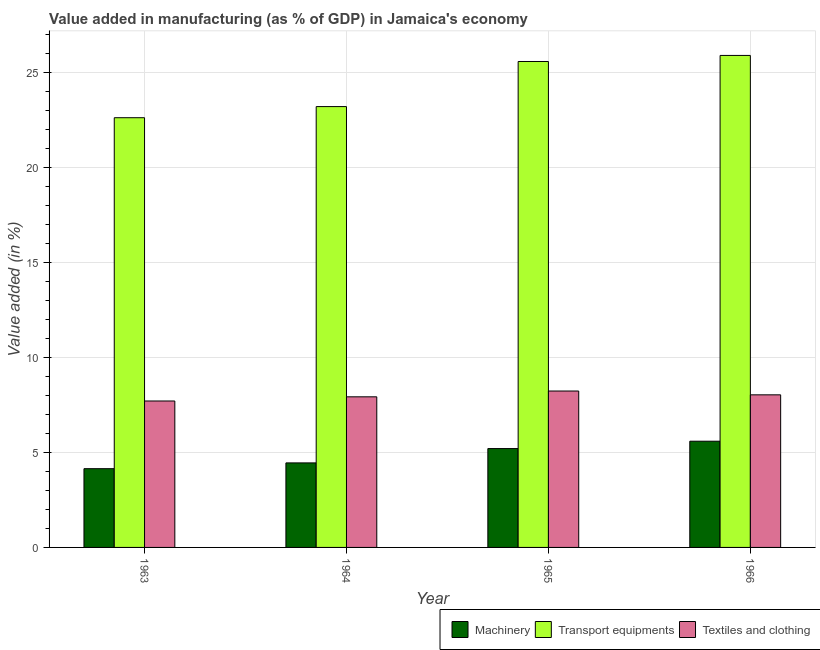How many bars are there on the 1st tick from the right?
Ensure brevity in your answer.  3. What is the label of the 3rd group of bars from the left?
Your answer should be compact. 1965. What is the value added in manufacturing transport equipments in 1964?
Provide a succinct answer. 23.21. Across all years, what is the maximum value added in manufacturing transport equipments?
Your answer should be very brief. 25.9. Across all years, what is the minimum value added in manufacturing transport equipments?
Offer a very short reply. 22.62. In which year was the value added in manufacturing transport equipments maximum?
Offer a terse response. 1966. In which year was the value added in manufacturing machinery minimum?
Offer a terse response. 1963. What is the total value added in manufacturing machinery in the graph?
Make the answer very short. 19.39. What is the difference between the value added in manufacturing machinery in 1963 and that in 1966?
Offer a very short reply. -1.45. What is the difference between the value added in manufacturing transport equipments in 1966 and the value added in manufacturing textile and clothing in 1964?
Your answer should be very brief. 2.69. What is the average value added in manufacturing textile and clothing per year?
Your response must be concise. 7.98. In the year 1966, what is the difference between the value added in manufacturing machinery and value added in manufacturing transport equipments?
Keep it short and to the point. 0. In how many years, is the value added in manufacturing machinery greater than 3 %?
Your response must be concise. 4. What is the ratio of the value added in manufacturing machinery in 1964 to that in 1965?
Give a very brief answer. 0.86. Is the difference between the value added in manufacturing transport equipments in 1963 and 1965 greater than the difference between the value added in manufacturing textile and clothing in 1963 and 1965?
Make the answer very short. No. What is the difference between the highest and the second highest value added in manufacturing textile and clothing?
Your response must be concise. 0.2. What is the difference between the highest and the lowest value added in manufacturing machinery?
Your response must be concise. 1.45. What does the 3rd bar from the left in 1963 represents?
Ensure brevity in your answer.  Textiles and clothing. What does the 3rd bar from the right in 1966 represents?
Your answer should be compact. Machinery. Are all the bars in the graph horizontal?
Your response must be concise. No. Does the graph contain any zero values?
Provide a short and direct response. No. How many legend labels are there?
Offer a terse response. 3. How are the legend labels stacked?
Provide a succinct answer. Horizontal. What is the title of the graph?
Provide a short and direct response. Value added in manufacturing (as % of GDP) in Jamaica's economy. Does "Ireland" appear as one of the legend labels in the graph?
Provide a short and direct response. No. What is the label or title of the X-axis?
Keep it short and to the point. Year. What is the label or title of the Y-axis?
Your answer should be compact. Value added (in %). What is the Value added (in %) of Machinery in 1963?
Provide a short and direct response. 4.15. What is the Value added (in %) in Transport equipments in 1963?
Provide a succinct answer. 22.62. What is the Value added (in %) in Textiles and clothing in 1963?
Make the answer very short. 7.71. What is the Value added (in %) in Machinery in 1964?
Keep it short and to the point. 4.45. What is the Value added (in %) of Transport equipments in 1964?
Provide a short and direct response. 23.21. What is the Value added (in %) in Textiles and clothing in 1964?
Provide a succinct answer. 7.93. What is the Value added (in %) in Machinery in 1965?
Your answer should be very brief. 5.2. What is the Value added (in %) of Transport equipments in 1965?
Your answer should be compact. 25.58. What is the Value added (in %) in Textiles and clothing in 1965?
Keep it short and to the point. 8.23. What is the Value added (in %) in Machinery in 1966?
Ensure brevity in your answer.  5.59. What is the Value added (in %) in Transport equipments in 1966?
Make the answer very short. 25.9. What is the Value added (in %) of Textiles and clothing in 1966?
Give a very brief answer. 8.03. Across all years, what is the maximum Value added (in %) of Machinery?
Your answer should be compact. 5.59. Across all years, what is the maximum Value added (in %) of Transport equipments?
Your answer should be very brief. 25.9. Across all years, what is the maximum Value added (in %) in Textiles and clothing?
Keep it short and to the point. 8.23. Across all years, what is the minimum Value added (in %) in Machinery?
Provide a succinct answer. 4.15. Across all years, what is the minimum Value added (in %) of Transport equipments?
Make the answer very short. 22.62. Across all years, what is the minimum Value added (in %) of Textiles and clothing?
Your answer should be very brief. 7.71. What is the total Value added (in %) in Machinery in the graph?
Make the answer very short. 19.39. What is the total Value added (in %) in Transport equipments in the graph?
Ensure brevity in your answer.  97.32. What is the total Value added (in %) in Textiles and clothing in the graph?
Provide a succinct answer. 31.91. What is the difference between the Value added (in %) of Machinery in 1963 and that in 1964?
Your answer should be very brief. -0.3. What is the difference between the Value added (in %) of Transport equipments in 1963 and that in 1964?
Offer a very short reply. -0.59. What is the difference between the Value added (in %) of Textiles and clothing in 1963 and that in 1964?
Provide a succinct answer. -0.22. What is the difference between the Value added (in %) in Machinery in 1963 and that in 1965?
Your response must be concise. -1.06. What is the difference between the Value added (in %) of Transport equipments in 1963 and that in 1965?
Your answer should be very brief. -2.96. What is the difference between the Value added (in %) in Textiles and clothing in 1963 and that in 1965?
Ensure brevity in your answer.  -0.52. What is the difference between the Value added (in %) of Machinery in 1963 and that in 1966?
Give a very brief answer. -1.45. What is the difference between the Value added (in %) in Transport equipments in 1963 and that in 1966?
Provide a short and direct response. -3.28. What is the difference between the Value added (in %) in Textiles and clothing in 1963 and that in 1966?
Your response must be concise. -0.32. What is the difference between the Value added (in %) of Machinery in 1964 and that in 1965?
Provide a short and direct response. -0.75. What is the difference between the Value added (in %) in Transport equipments in 1964 and that in 1965?
Provide a short and direct response. -2.37. What is the difference between the Value added (in %) of Textiles and clothing in 1964 and that in 1965?
Offer a very short reply. -0.3. What is the difference between the Value added (in %) in Machinery in 1964 and that in 1966?
Your answer should be very brief. -1.14. What is the difference between the Value added (in %) of Transport equipments in 1964 and that in 1966?
Give a very brief answer. -2.69. What is the difference between the Value added (in %) of Textiles and clothing in 1964 and that in 1966?
Your answer should be compact. -0.1. What is the difference between the Value added (in %) in Machinery in 1965 and that in 1966?
Keep it short and to the point. -0.39. What is the difference between the Value added (in %) of Transport equipments in 1965 and that in 1966?
Give a very brief answer. -0.32. What is the difference between the Value added (in %) of Textiles and clothing in 1965 and that in 1966?
Your answer should be compact. 0.2. What is the difference between the Value added (in %) of Machinery in 1963 and the Value added (in %) of Transport equipments in 1964?
Offer a terse response. -19.06. What is the difference between the Value added (in %) of Machinery in 1963 and the Value added (in %) of Textiles and clothing in 1964?
Give a very brief answer. -3.78. What is the difference between the Value added (in %) in Transport equipments in 1963 and the Value added (in %) in Textiles and clothing in 1964?
Keep it short and to the point. 14.69. What is the difference between the Value added (in %) in Machinery in 1963 and the Value added (in %) in Transport equipments in 1965?
Provide a short and direct response. -21.44. What is the difference between the Value added (in %) of Machinery in 1963 and the Value added (in %) of Textiles and clothing in 1965?
Make the answer very short. -4.09. What is the difference between the Value added (in %) of Transport equipments in 1963 and the Value added (in %) of Textiles and clothing in 1965?
Provide a succinct answer. 14.39. What is the difference between the Value added (in %) of Machinery in 1963 and the Value added (in %) of Transport equipments in 1966?
Keep it short and to the point. -21.76. What is the difference between the Value added (in %) in Machinery in 1963 and the Value added (in %) in Textiles and clothing in 1966?
Offer a very short reply. -3.89. What is the difference between the Value added (in %) in Transport equipments in 1963 and the Value added (in %) in Textiles and clothing in 1966?
Provide a succinct answer. 14.59. What is the difference between the Value added (in %) of Machinery in 1964 and the Value added (in %) of Transport equipments in 1965?
Ensure brevity in your answer.  -21.13. What is the difference between the Value added (in %) of Machinery in 1964 and the Value added (in %) of Textiles and clothing in 1965?
Offer a very short reply. -3.78. What is the difference between the Value added (in %) of Transport equipments in 1964 and the Value added (in %) of Textiles and clothing in 1965?
Offer a terse response. 14.97. What is the difference between the Value added (in %) in Machinery in 1964 and the Value added (in %) in Transport equipments in 1966?
Keep it short and to the point. -21.45. What is the difference between the Value added (in %) of Machinery in 1964 and the Value added (in %) of Textiles and clothing in 1966?
Provide a succinct answer. -3.58. What is the difference between the Value added (in %) in Transport equipments in 1964 and the Value added (in %) in Textiles and clothing in 1966?
Provide a short and direct response. 15.18. What is the difference between the Value added (in %) in Machinery in 1965 and the Value added (in %) in Transport equipments in 1966?
Offer a terse response. -20.7. What is the difference between the Value added (in %) of Machinery in 1965 and the Value added (in %) of Textiles and clothing in 1966?
Make the answer very short. -2.83. What is the difference between the Value added (in %) in Transport equipments in 1965 and the Value added (in %) in Textiles and clothing in 1966?
Provide a succinct answer. 17.55. What is the average Value added (in %) of Machinery per year?
Your answer should be compact. 4.85. What is the average Value added (in %) in Transport equipments per year?
Make the answer very short. 24.33. What is the average Value added (in %) in Textiles and clothing per year?
Make the answer very short. 7.98. In the year 1963, what is the difference between the Value added (in %) in Machinery and Value added (in %) in Transport equipments?
Offer a very short reply. -18.48. In the year 1963, what is the difference between the Value added (in %) of Machinery and Value added (in %) of Textiles and clothing?
Provide a succinct answer. -3.56. In the year 1963, what is the difference between the Value added (in %) in Transport equipments and Value added (in %) in Textiles and clothing?
Offer a terse response. 14.91. In the year 1964, what is the difference between the Value added (in %) of Machinery and Value added (in %) of Transport equipments?
Your answer should be very brief. -18.76. In the year 1964, what is the difference between the Value added (in %) in Machinery and Value added (in %) in Textiles and clothing?
Provide a short and direct response. -3.48. In the year 1964, what is the difference between the Value added (in %) of Transport equipments and Value added (in %) of Textiles and clothing?
Give a very brief answer. 15.28. In the year 1965, what is the difference between the Value added (in %) in Machinery and Value added (in %) in Transport equipments?
Your response must be concise. -20.38. In the year 1965, what is the difference between the Value added (in %) of Machinery and Value added (in %) of Textiles and clothing?
Your answer should be compact. -3.03. In the year 1965, what is the difference between the Value added (in %) in Transport equipments and Value added (in %) in Textiles and clothing?
Provide a short and direct response. 17.35. In the year 1966, what is the difference between the Value added (in %) of Machinery and Value added (in %) of Transport equipments?
Offer a terse response. -20.31. In the year 1966, what is the difference between the Value added (in %) in Machinery and Value added (in %) in Textiles and clothing?
Provide a short and direct response. -2.44. In the year 1966, what is the difference between the Value added (in %) of Transport equipments and Value added (in %) of Textiles and clothing?
Ensure brevity in your answer.  17.87. What is the ratio of the Value added (in %) of Machinery in 1963 to that in 1964?
Your answer should be compact. 0.93. What is the ratio of the Value added (in %) in Transport equipments in 1963 to that in 1964?
Make the answer very short. 0.97. What is the ratio of the Value added (in %) in Textiles and clothing in 1963 to that in 1964?
Ensure brevity in your answer.  0.97. What is the ratio of the Value added (in %) of Machinery in 1963 to that in 1965?
Provide a succinct answer. 0.8. What is the ratio of the Value added (in %) in Transport equipments in 1963 to that in 1965?
Keep it short and to the point. 0.88. What is the ratio of the Value added (in %) in Textiles and clothing in 1963 to that in 1965?
Offer a terse response. 0.94. What is the ratio of the Value added (in %) of Machinery in 1963 to that in 1966?
Offer a terse response. 0.74. What is the ratio of the Value added (in %) in Transport equipments in 1963 to that in 1966?
Provide a short and direct response. 0.87. What is the ratio of the Value added (in %) of Textiles and clothing in 1963 to that in 1966?
Keep it short and to the point. 0.96. What is the ratio of the Value added (in %) of Machinery in 1964 to that in 1965?
Offer a very short reply. 0.86. What is the ratio of the Value added (in %) of Transport equipments in 1964 to that in 1965?
Your answer should be compact. 0.91. What is the ratio of the Value added (in %) in Textiles and clothing in 1964 to that in 1965?
Provide a succinct answer. 0.96. What is the ratio of the Value added (in %) of Machinery in 1964 to that in 1966?
Offer a very short reply. 0.8. What is the ratio of the Value added (in %) of Transport equipments in 1964 to that in 1966?
Your answer should be compact. 0.9. What is the ratio of the Value added (in %) of Machinery in 1965 to that in 1966?
Your answer should be very brief. 0.93. What is the ratio of the Value added (in %) in Transport equipments in 1965 to that in 1966?
Offer a very short reply. 0.99. What is the difference between the highest and the second highest Value added (in %) of Machinery?
Ensure brevity in your answer.  0.39. What is the difference between the highest and the second highest Value added (in %) in Transport equipments?
Offer a terse response. 0.32. What is the difference between the highest and the second highest Value added (in %) in Textiles and clothing?
Provide a short and direct response. 0.2. What is the difference between the highest and the lowest Value added (in %) in Machinery?
Your answer should be compact. 1.45. What is the difference between the highest and the lowest Value added (in %) of Transport equipments?
Provide a short and direct response. 3.28. What is the difference between the highest and the lowest Value added (in %) of Textiles and clothing?
Your answer should be very brief. 0.52. 